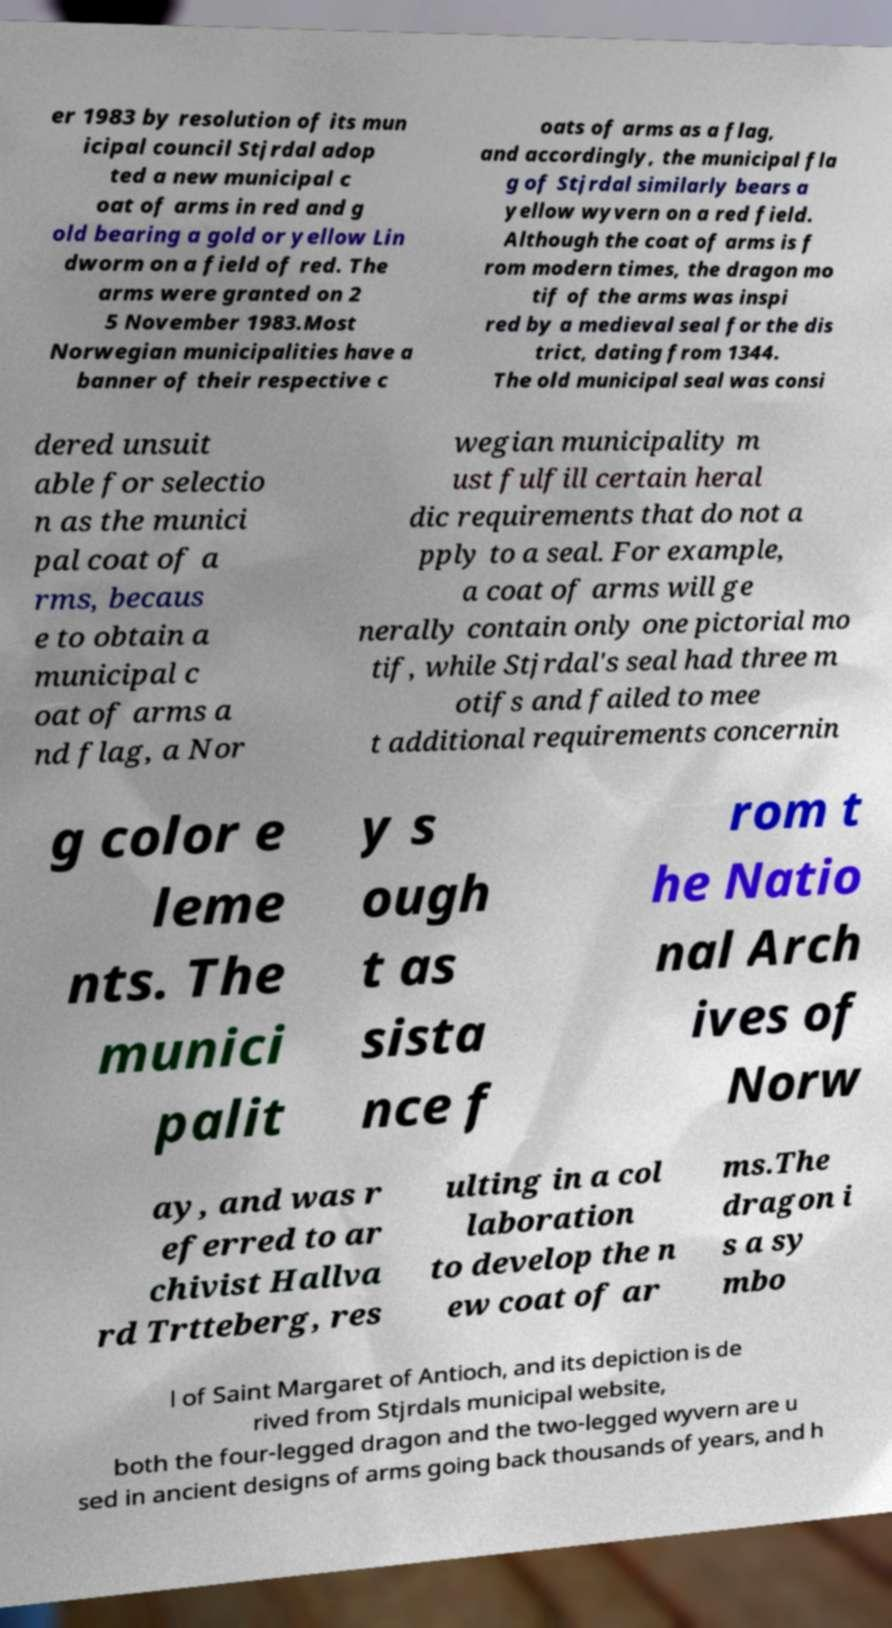Can you accurately transcribe the text from the provided image for me? er 1983 by resolution of its mun icipal council Stjrdal adop ted a new municipal c oat of arms in red and g old bearing a gold or yellow Lin dworm on a field of red. The arms were granted on 2 5 November 1983.Most Norwegian municipalities have a banner of their respective c oats of arms as a flag, and accordingly, the municipal fla g of Stjrdal similarly bears a yellow wyvern on a red field. Although the coat of arms is f rom modern times, the dragon mo tif of the arms was inspi red by a medieval seal for the dis trict, dating from 1344. The old municipal seal was consi dered unsuit able for selectio n as the munici pal coat of a rms, becaus e to obtain a municipal c oat of arms a nd flag, a Nor wegian municipality m ust fulfill certain heral dic requirements that do not a pply to a seal. For example, a coat of arms will ge nerally contain only one pictorial mo tif, while Stjrdal's seal had three m otifs and failed to mee t additional requirements concernin g color e leme nts. The munici palit y s ough t as sista nce f rom t he Natio nal Arch ives of Norw ay, and was r eferred to ar chivist Hallva rd Trtteberg, res ulting in a col laboration to develop the n ew coat of ar ms.The dragon i s a sy mbo l of Saint Margaret of Antioch, and its depiction is de rived from Stjrdals municipal website, both the four-legged dragon and the two-legged wyvern are u sed in ancient designs of arms going back thousands of years, and h 